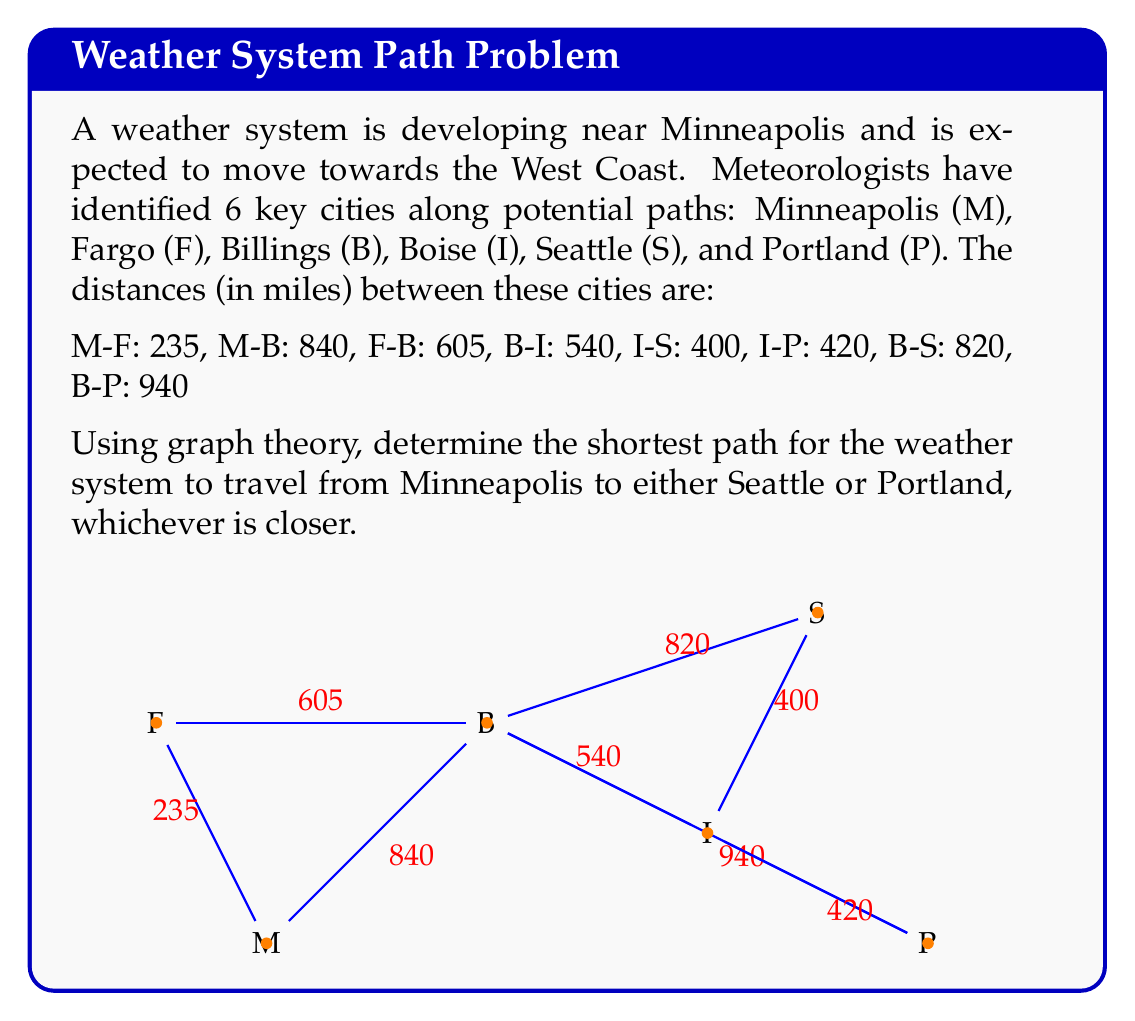Can you solve this math problem? To solve this problem, we'll use Dijkstra's algorithm to find the shortest path from Minneapolis to both Seattle and Portland. Then, we'll compare the total distances to determine the overall shortest path.

Step 1: Apply Dijkstra's algorithm from Minneapolis (M) to all other vertices.

Initialize:
M: 0
F: ∞
B: ∞
I: ∞
S: ∞
P: ∞

Iterations:
1. M → F: 235, M → B: 840
   Updated: F: 235, B: 840
2. F → B: 235 + 605 = 840 (no update)
3. B → I: 840 + 540 = 1380
   Updated: I: 1380
4. I → S: 1380 + 400 = 1780
   I → P: 1380 + 420 = 1800
   Updated: S: 1780, P: 1800
5. B → S: 840 + 820 = 1660 (update S)
   B → P: 840 + 940 = 1780 (update P)
   Updated: S: 1660, P: 1780

Step 2: Identify the shortest paths:
To Seattle: M → B → S (1660 miles)
To Portland: M → B → P (1780 miles)

Step 3: Compare the distances:
Seattle: 1660 miles
Portland: 1780 miles

The shortest path is to Seattle, which is 120 miles shorter than the path to Portland.
Answer: The shortest path for the weather system to travel from Minneapolis to the West Coast is Minneapolis → Billings → Seattle, with a total distance of 1660 miles. 